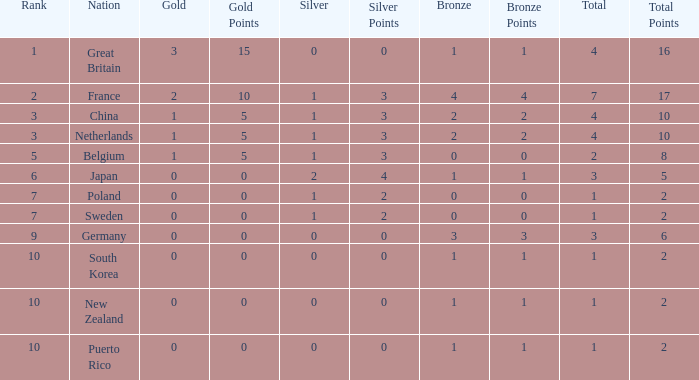What is the rank with 0 bronze? None. 